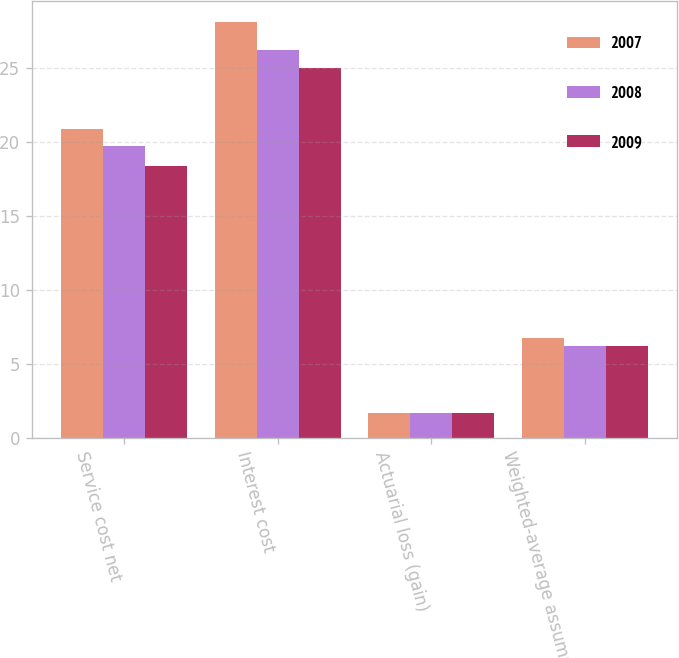Convert chart. <chart><loc_0><loc_0><loc_500><loc_500><stacked_bar_chart><ecel><fcel>Service cost net<fcel>Interest cost<fcel>Actuarial loss (gain)<fcel>Weighted-average assumptions<nl><fcel>2007<fcel>20.9<fcel>28.1<fcel>1.7<fcel>6.75<nl><fcel>2008<fcel>19.7<fcel>26.2<fcel>1.7<fcel>6.25<nl><fcel>2009<fcel>18.4<fcel>25<fcel>1.7<fcel>6.25<nl></chart> 